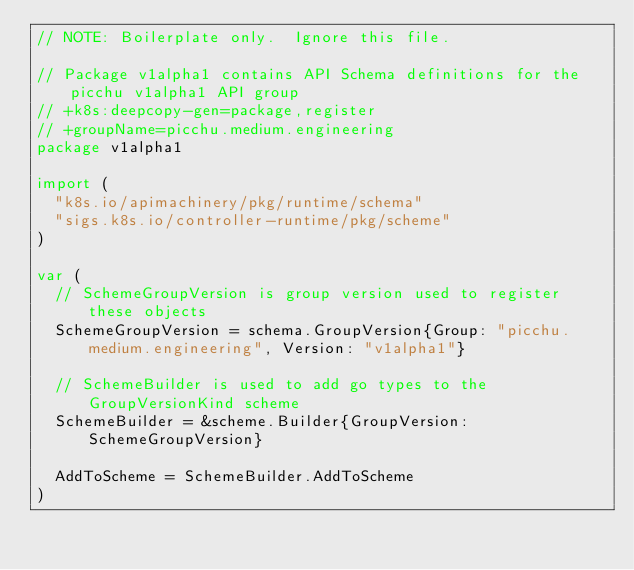<code> <loc_0><loc_0><loc_500><loc_500><_Go_>// NOTE: Boilerplate only.  Ignore this file.

// Package v1alpha1 contains API Schema definitions for the picchu v1alpha1 API group
// +k8s:deepcopy-gen=package,register
// +groupName=picchu.medium.engineering
package v1alpha1

import (
	"k8s.io/apimachinery/pkg/runtime/schema"
	"sigs.k8s.io/controller-runtime/pkg/scheme"
)

var (
	// SchemeGroupVersion is group version used to register these objects
	SchemeGroupVersion = schema.GroupVersion{Group: "picchu.medium.engineering", Version: "v1alpha1"}

	// SchemeBuilder is used to add go types to the GroupVersionKind scheme
	SchemeBuilder = &scheme.Builder{GroupVersion: SchemeGroupVersion}

	AddToScheme = SchemeBuilder.AddToScheme
)
</code> 